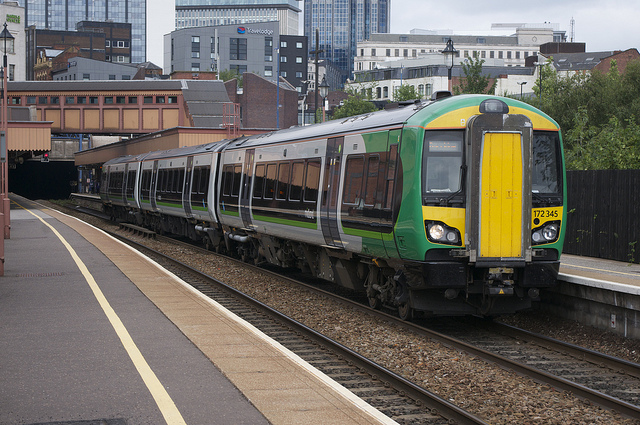Please identify all text content in this image. 345 172 